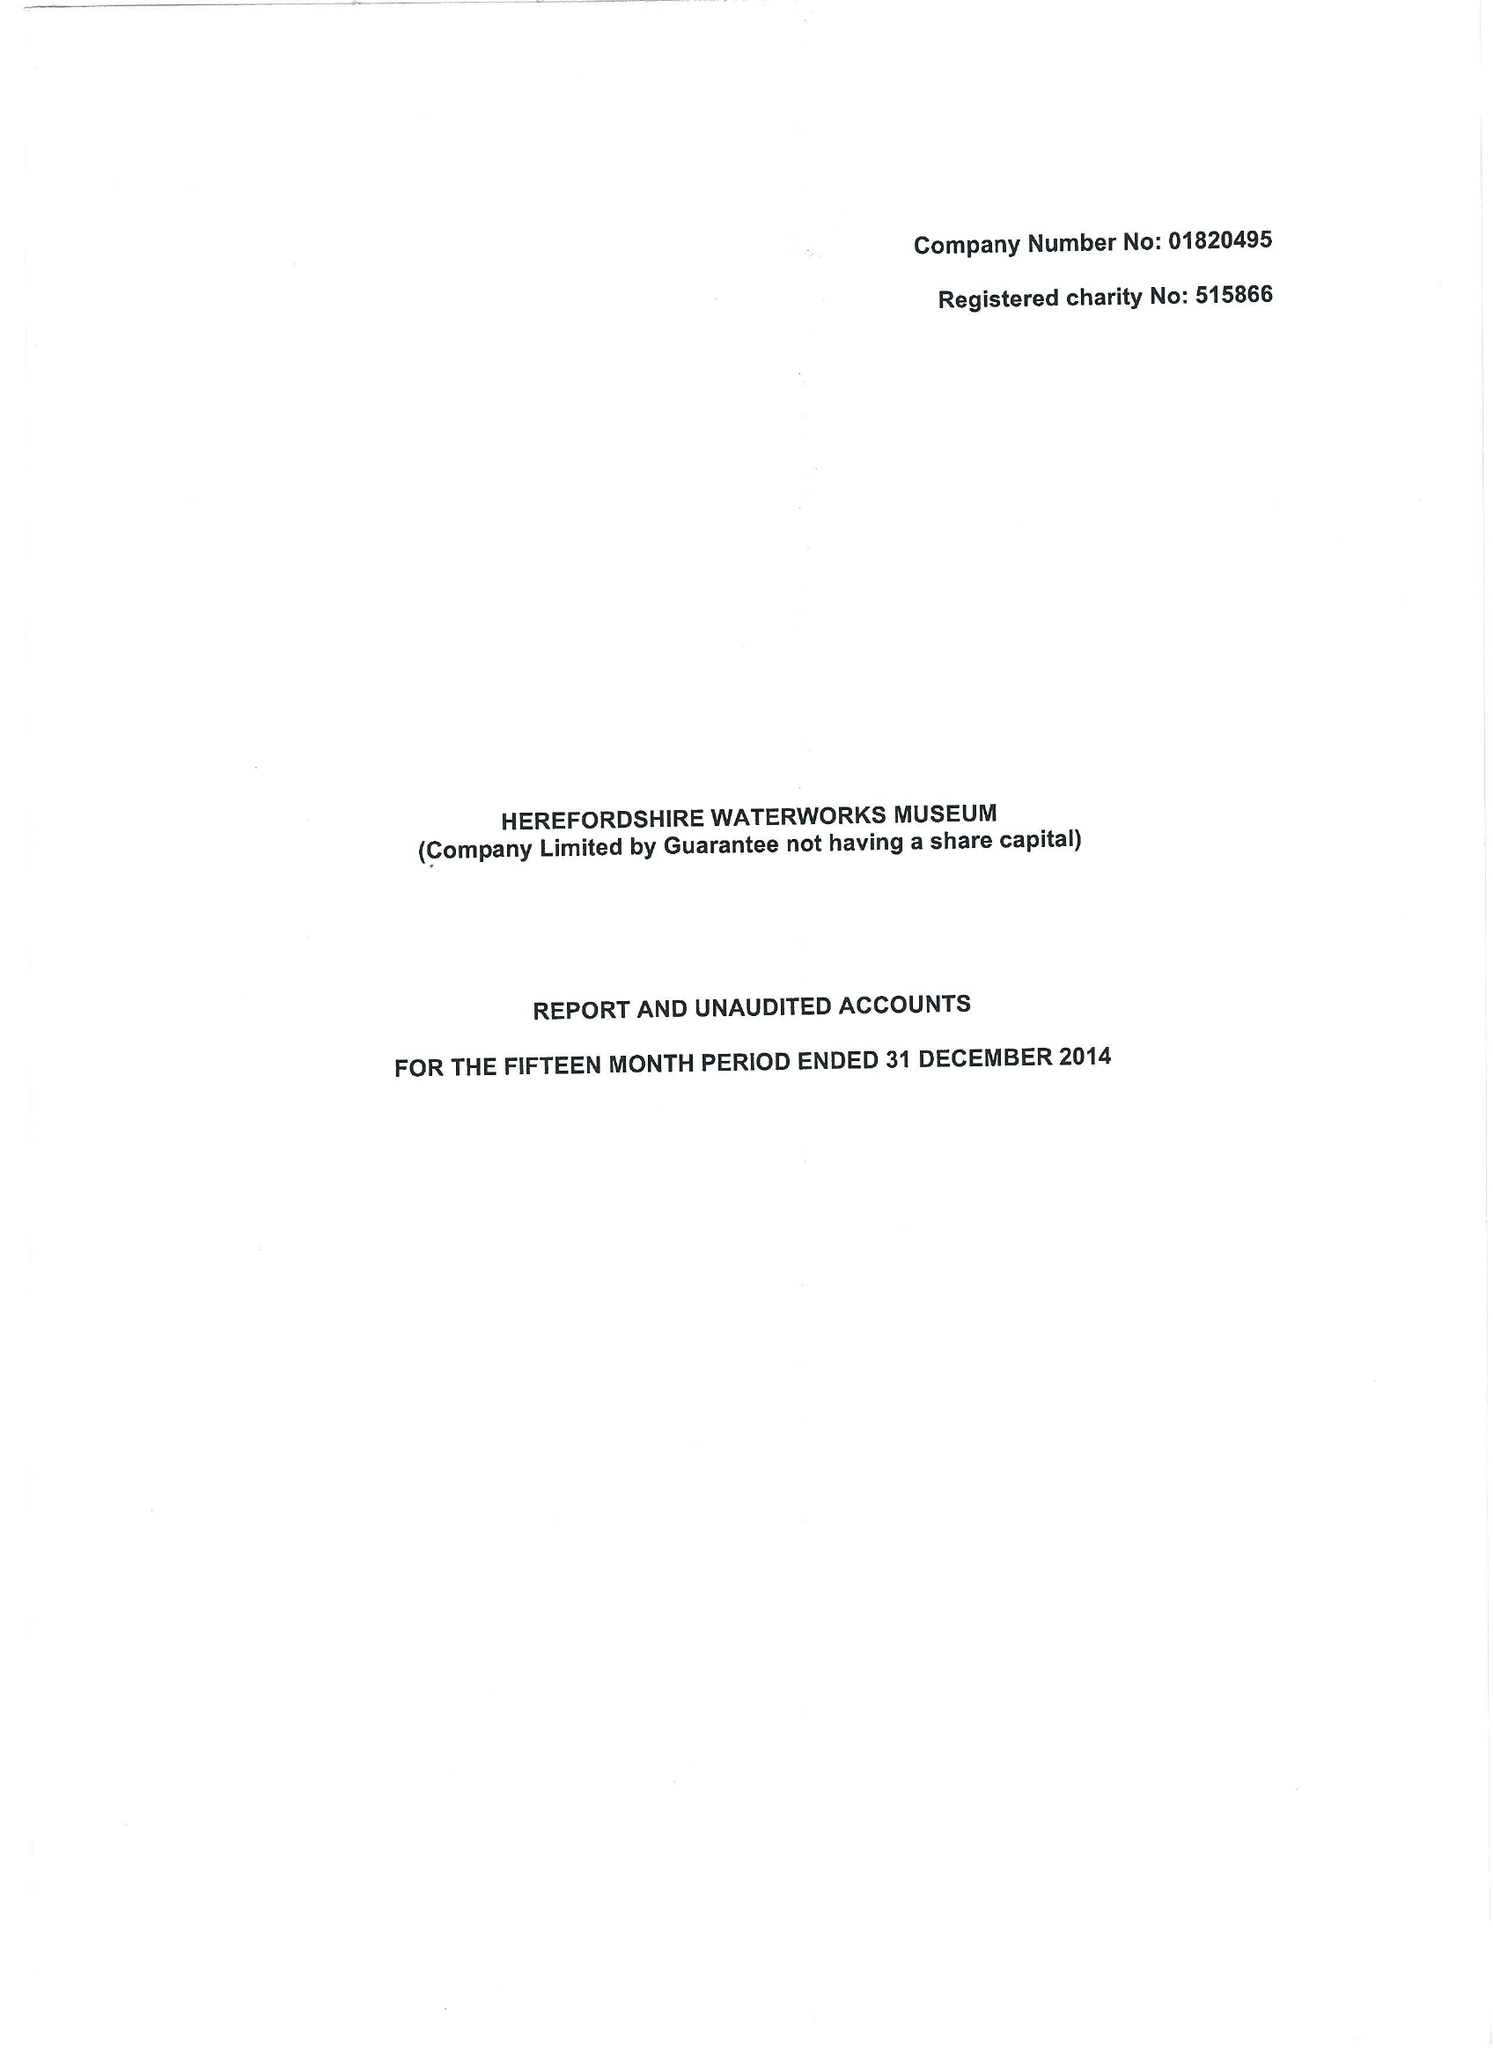What is the value for the address__post_town?
Answer the question using a single word or phrase. HEREFORD 